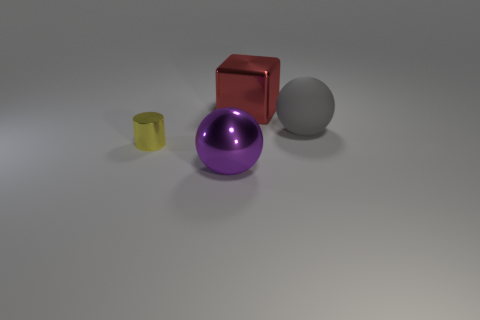Are there an equal number of shiny spheres to the left of the small metallic object and large purple rubber balls?
Offer a very short reply. Yes. Do the gray matte thing and the cube left of the large rubber ball have the same size?
Your response must be concise. Yes. What number of other objects are the same size as the purple sphere?
Your answer should be very brief. 2. How many other objects are the same color as the tiny shiny cylinder?
Give a very brief answer. 0. Are there any other things that are the same size as the matte ball?
Provide a succinct answer. Yes. What number of other objects are there of the same shape as the gray object?
Your answer should be very brief. 1. Is the size of the metal cylinder the same as the metal ball?
Offer a very short reply. No. Are there any small yellow objects?
Your response must be concise. Yes. Are there any other things that have the same material as the big purple object?
Your response must be concise. Yes. Are there any purple spheres made of the same material as the large red thing?
Offer a terse response. Yes. 